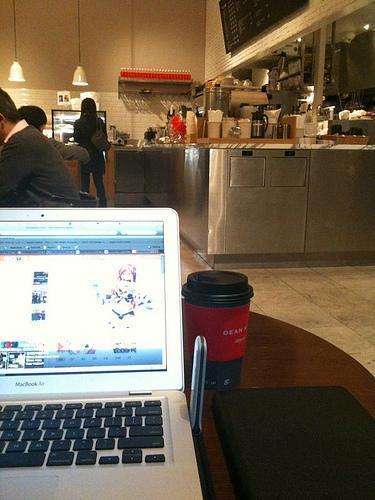How many people are in the picture?
Give a very brief answer. 2. 